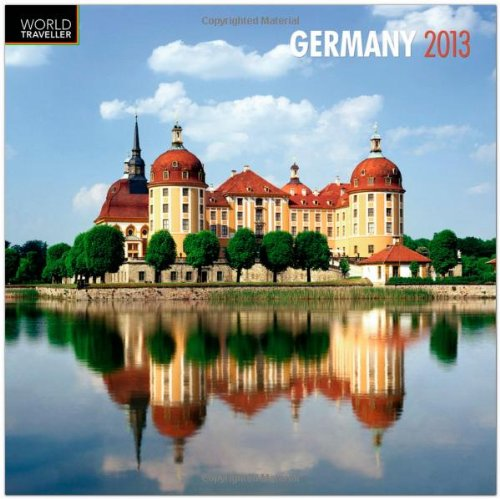What type of book is this? This item is categorized under 'Calendars', specifically designed for organizing dates and events throughout the year 2013, with a focus on Germany's picturesque landscapes. 